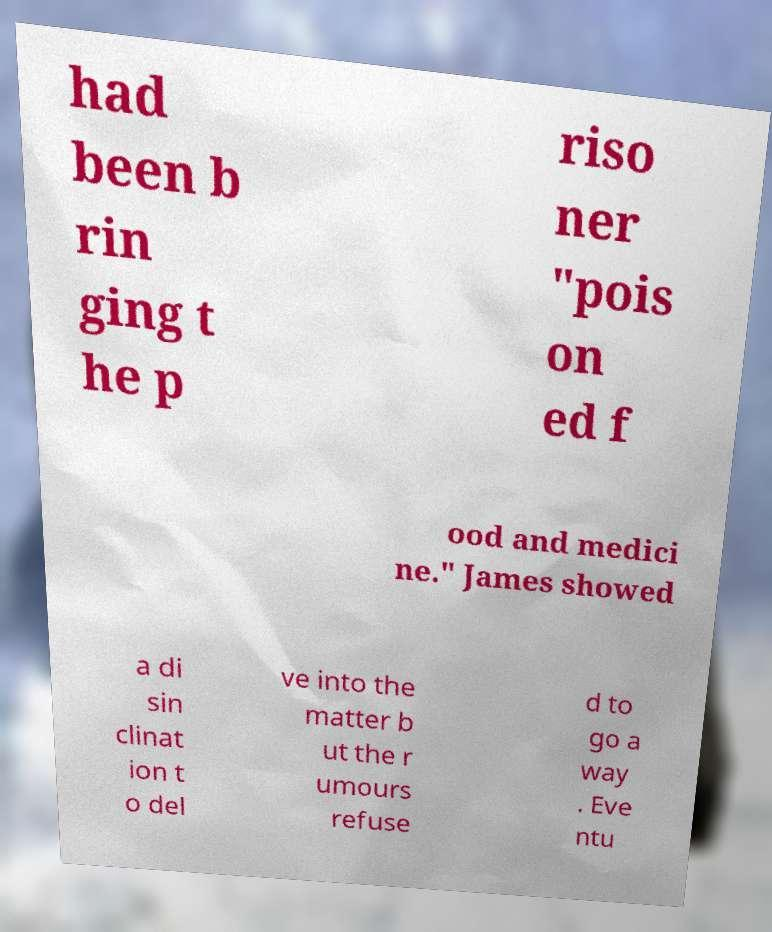Could you extract and type out the text from this image? had been b rin ging t he p riso ner "pois on ed f ood and medici ne." James showed a di sin clinat ion t o del ve into the matter b ut the r umours refuse d to go a way . Eve ntu 